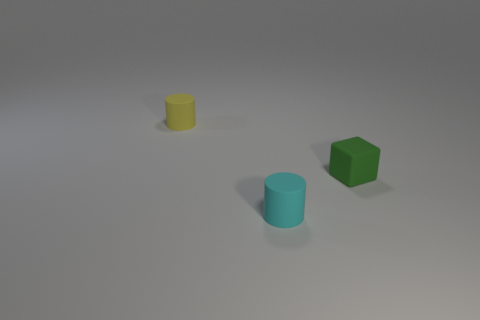There is a matte cylinder that is in front of the yellow rubber object; what number of cylinders are on the left side of it?
Your response must be concise. 1. There is a thing that is left of the cyan matte thing; does it have the same shape as the object that is in front of the cube?
Your answer should be compact. Yes. There is a rubber thing that is on the left side of the tiny green object and behind the cyan rubber cylinder; what is its size?
Offer a very short reply. Small. There is another tiny matte object that is the same shape as the cyan matte thing; what color is it?
Make the answer very short. Yellow. The tiny rubber thing behind the rubber object to the right of the cyan cylinder is what color?
Provide a succinct answer. Yellow. There is a tiny yellow object; what shape is it?
Provide a succinct answer. Cylinder. What shape is the thing that is behind the cyan object and on the left side of the green matte object?
Give a very brief answer. Cylinder. What is the color of the cylinder that is the same material as the yellow object?
Offer a terse response. Cyan. The rubber thing that is right of the rubber object that is in front of the small rubber thing to the right of the cyan matte thing is what shape?
Give a very brief answer. Cube. What size is the rubber block?
Offer a terse response. Small. 